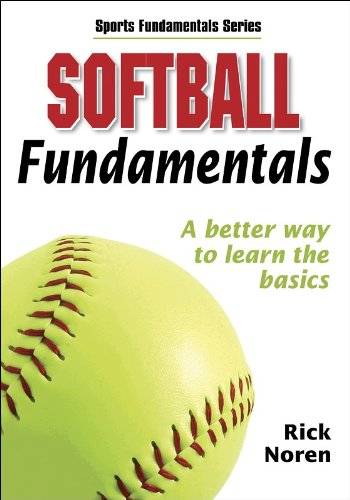What kind of additional resources does this book offer to help with learning softball? Alongside detailed instructional content, the book includes diagrams, practice drills, and expert tips to facilitate better learning and understanding of softball. 